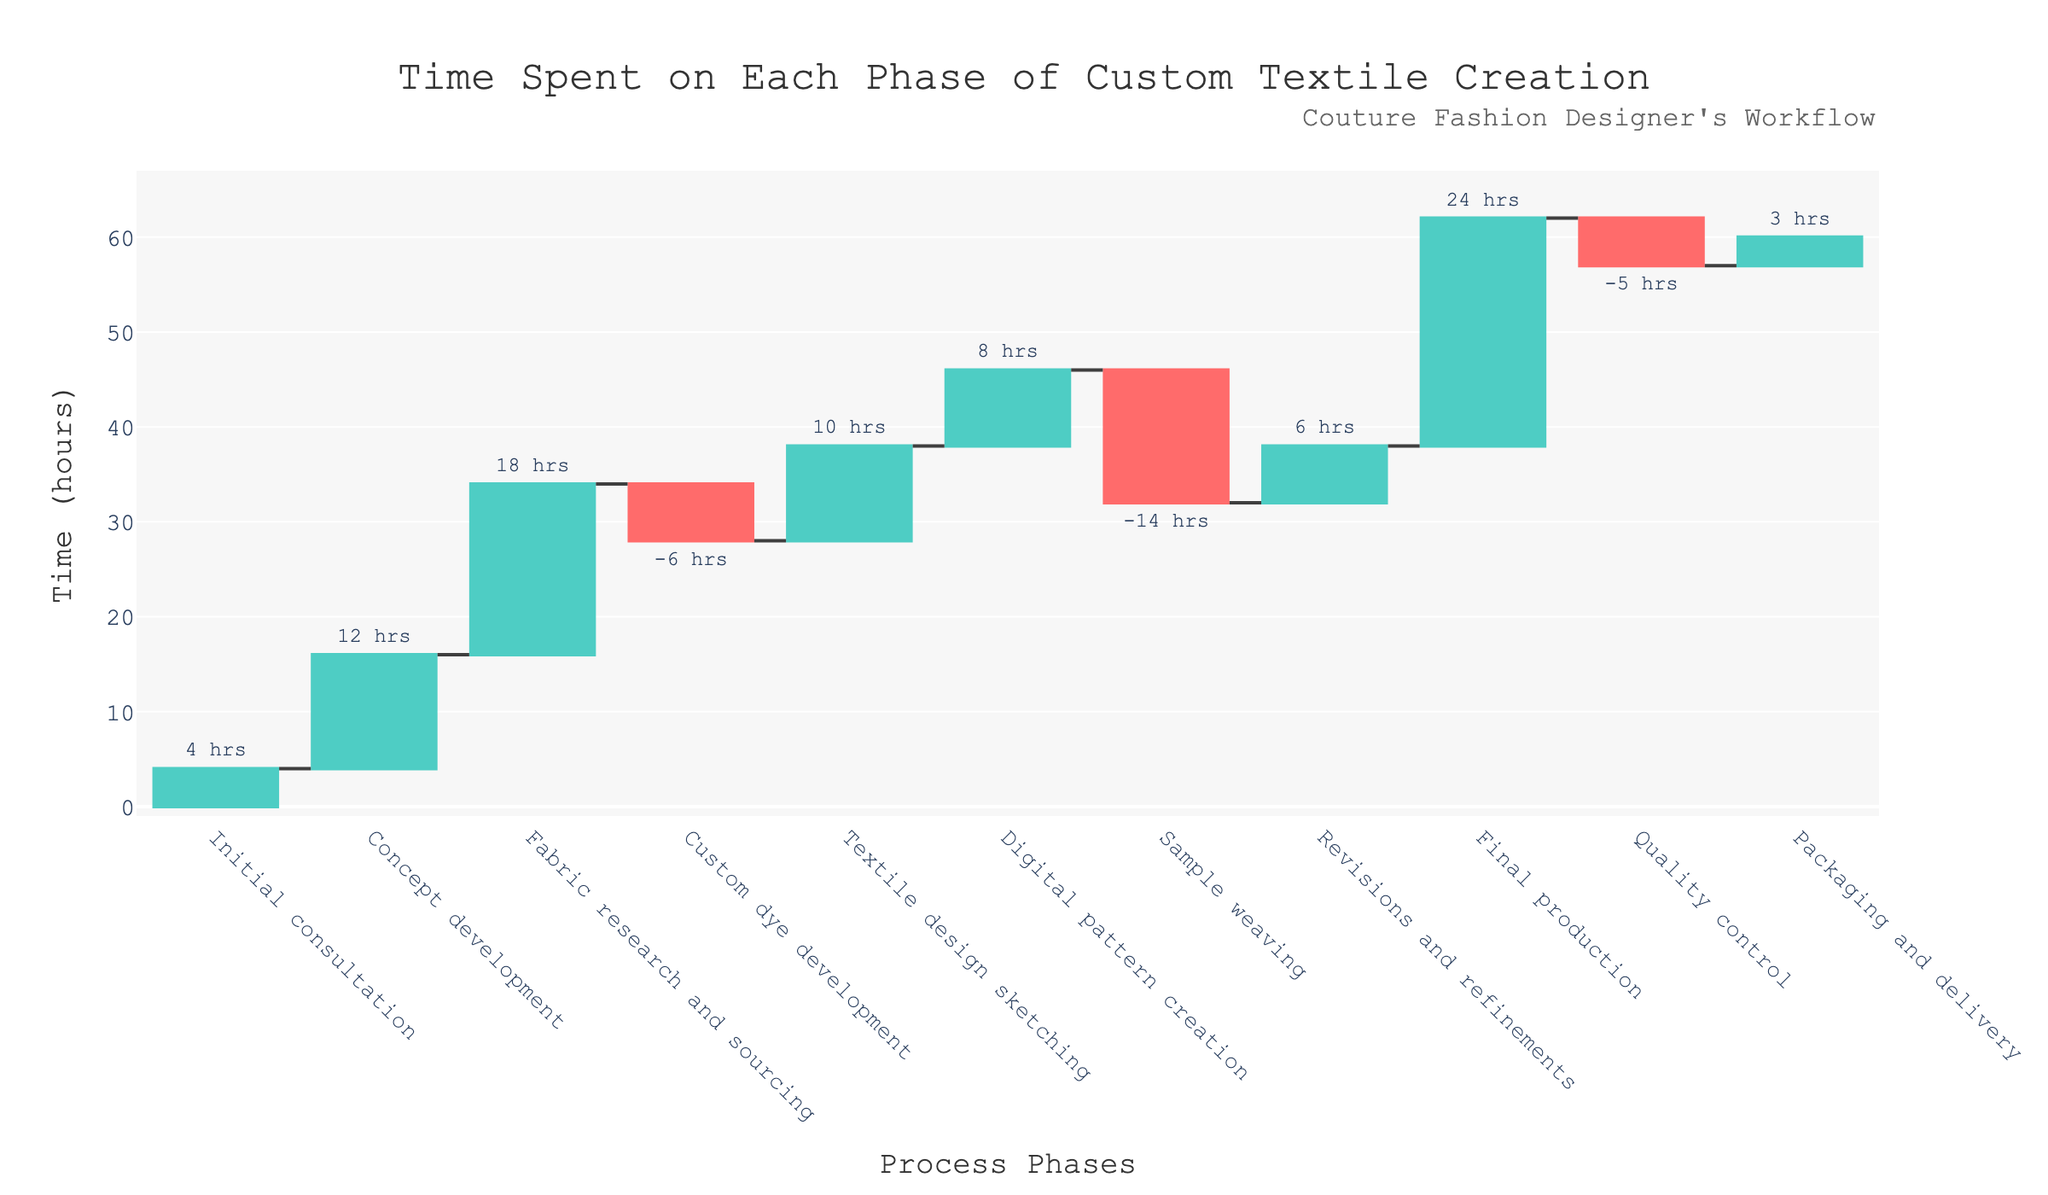what is the total time spent on initial consultation? The plot shows the total time spent and individual stages. The initial consultation stage shows a total time of 4 hours.
Answer: 4 hours what phase consumed the most time? By examining each phase and its time on the chart, the final production phase shows the largest time spent at 24 hours.
Answer: final production how much time did the custom dye development save? The custom dye development phase shows a negative value of -6 hours, indicating a time saving of 6 hours.
Answer: 6 hours What is the total time added by the initial consultation, concept development, and fabric research and sourcing phases? Adding the time spent on initial consultation (4 hours), concept development (12 hours), and fabric research and sourcing (18 hours) gives 4 + 12 + 18 = 34 hours.
Answer: 34 hours What is the overall time spent on the revisions and refinements phase? The plot indicates that the revisions and refinements phase took 6 hours in total.
Answer: 6 hours How does the time spent on sample weaving compare to the time saved during quality control? Sample weaving shows a time consumption of -14 hours, while quality control shows a time saving of -5 hours. Comparing these, sample weaving saved more time than quality control.
Answer: sample weaving saved more time What is the net result of all phases combined in terms of time spent? Adding the time of each phase cumulatively: 4 + 12 + 18 - 6 + 10 + 8 - 14 + 6 + 24 - 5 + 3 = 60 hours. The net result is 60 hours spent in total.
Answer: 60 hours What’s the total time reduction from phases with negative values? Phases with negative values are custom dye development (-6 hours), sample weaving (-14 hours), and quality control (-5 hours). Adding these gives -6 + (-14) + (-5) = -25. The total time reduction is 25 hours.
Answer: 25 hours What is the net time spent after the digital pattern creation phase? Summing up the times from the initial consultation through the digital pattern creation phase (4 + 12 + 18 - 6 + 10 + 8 = 46 hours) indicates the net time spent after the digital pattern creation phase is 46 hours.
Answer: 46 hours 